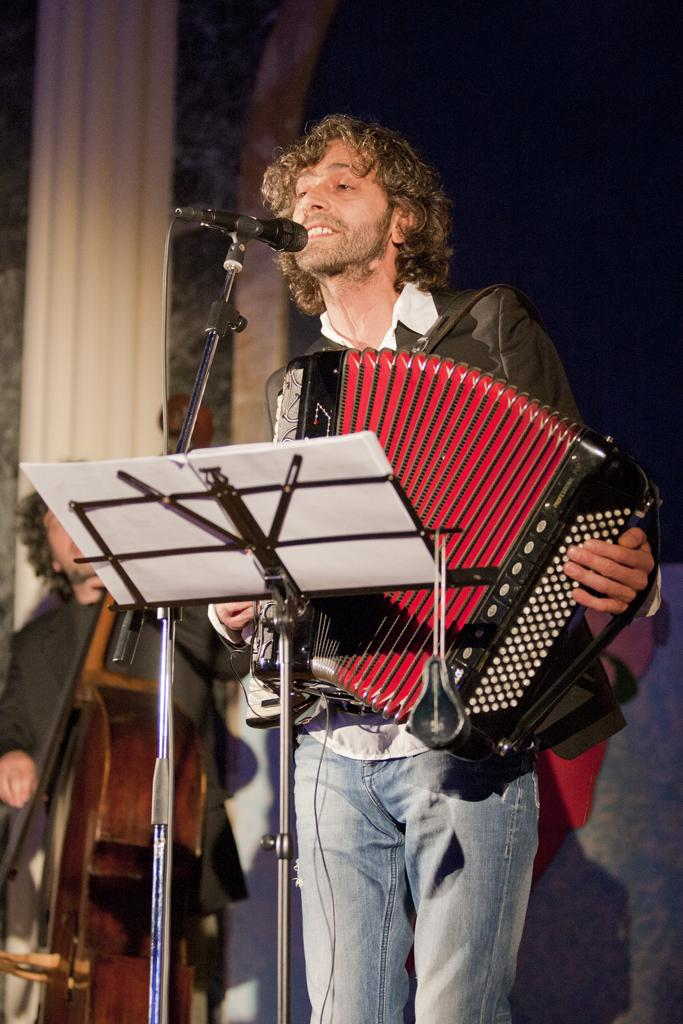How many people are in the image? There are two persons in the image. What are the persons doing in the image? Both persons are playing musical instruments. Can you describe the equipment in front of one of the persons? There is a microphone and stand in front of one of the persons. What can be seen in the background of the image? There is a wall in the background of the image. What type of ink is being used to write on the edge of the property in the image? There is no ink, edge, or property present in the image. 